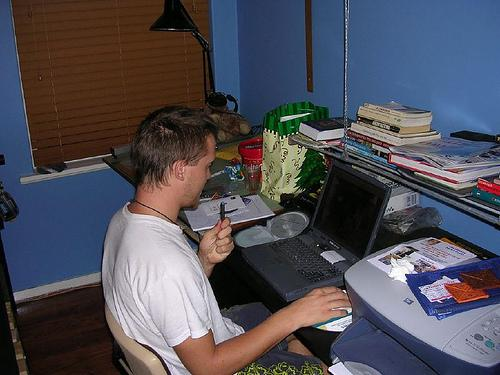What is he doing? Please explain your reasoning. recording voice. He has a black stick in his hand held up close to his face which he needs to speak into. 